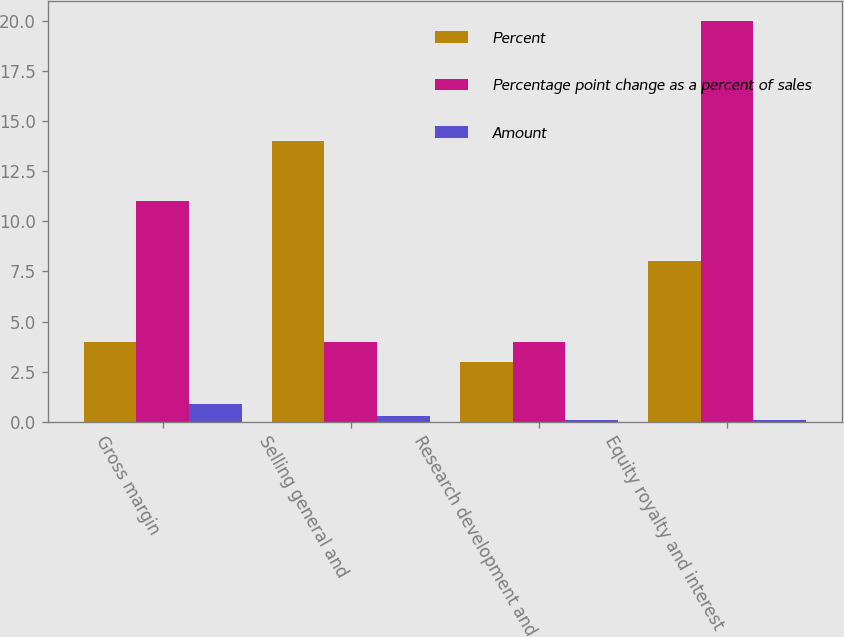<chart> <loc_0><loc_0><loc_500><loc_500><stacked_bar_chart><ecel><fcel>Gross margin<fcel>Selling general and<fcel>Research development and<fcel>Equity royalty and interest<nl><fcel>Percent<fcel>4<fcel>14<fcel>3<fcel>8<nl><fcel>Percentage point change as a percent of sales<fcel>11<fcel>4<fcel>4<fcel>20<nl><fcel>Amount<fcel>0.9<fcel>0.3<fcel>0.1<fcel>0.1<nl></chart> 